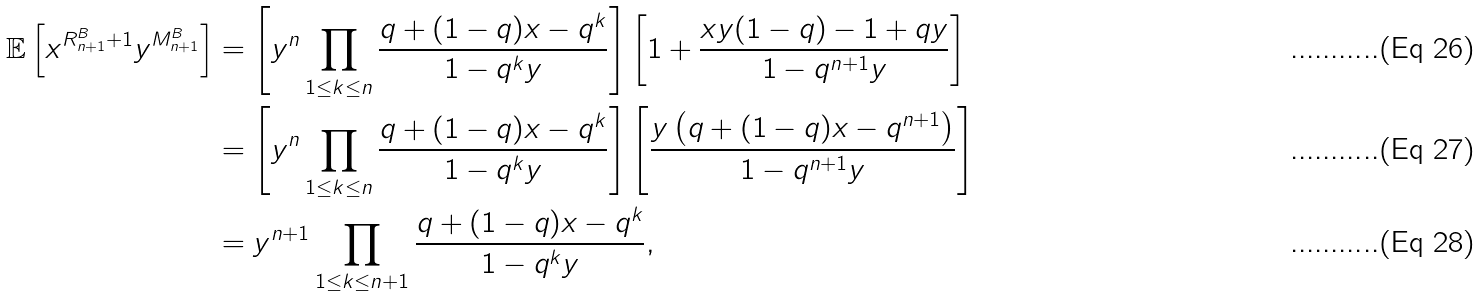Convert formula to latex. <formula><loc_0><loc_0><loc_500><loc_500>\mathbb { E } \left [ x ^ { R ^ { B } _ { n + 1 } + 1 } y ^ { M ^ { B } _ { n + 1 } } \right ] & = \left [ y ^ { n } \prod _ { 1 \leq k \leq n } \frac { q + ( 1 - q ) x - q ^ { k } } { 1 - q ^ { k } y } \right ] \left [ 1 + \frac { x y ( 1 - q ) - 1 + q y } { 1 - q ^ { n + 1 } y } \right ] \\ & = \left [ y ^ { n } \prod _ { 1 \leq k \leq n } \frac { q + ( 1 - q ) x - q ^ { k } } { 1 - q ^ { k } y } \right ] \left [ \frac { y \left ( q + ( 1 - q ) x - q ^ { n + 1 } \right ) } { 1 - q ^ { n + 1 } y } \right ] \\ & = y ^ { n + 1 } \prod _ { 1 \leq k \leq n + 1 } \frac { q + ( 1 - q ) x - q ^ { k } } { 1 - q ^ { k } y } ,</formula> 